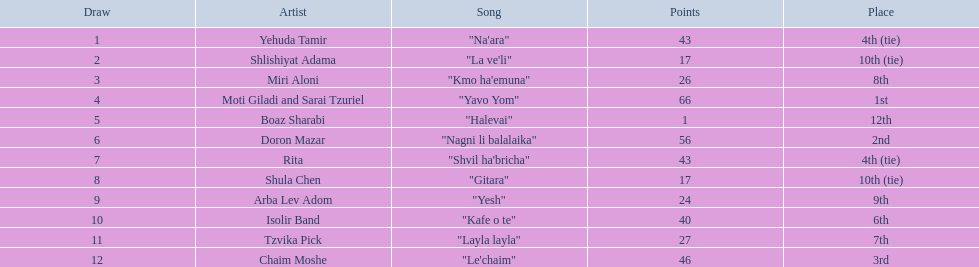Between "gitara" and "yesh", which song had a higher score? "Yesh". 